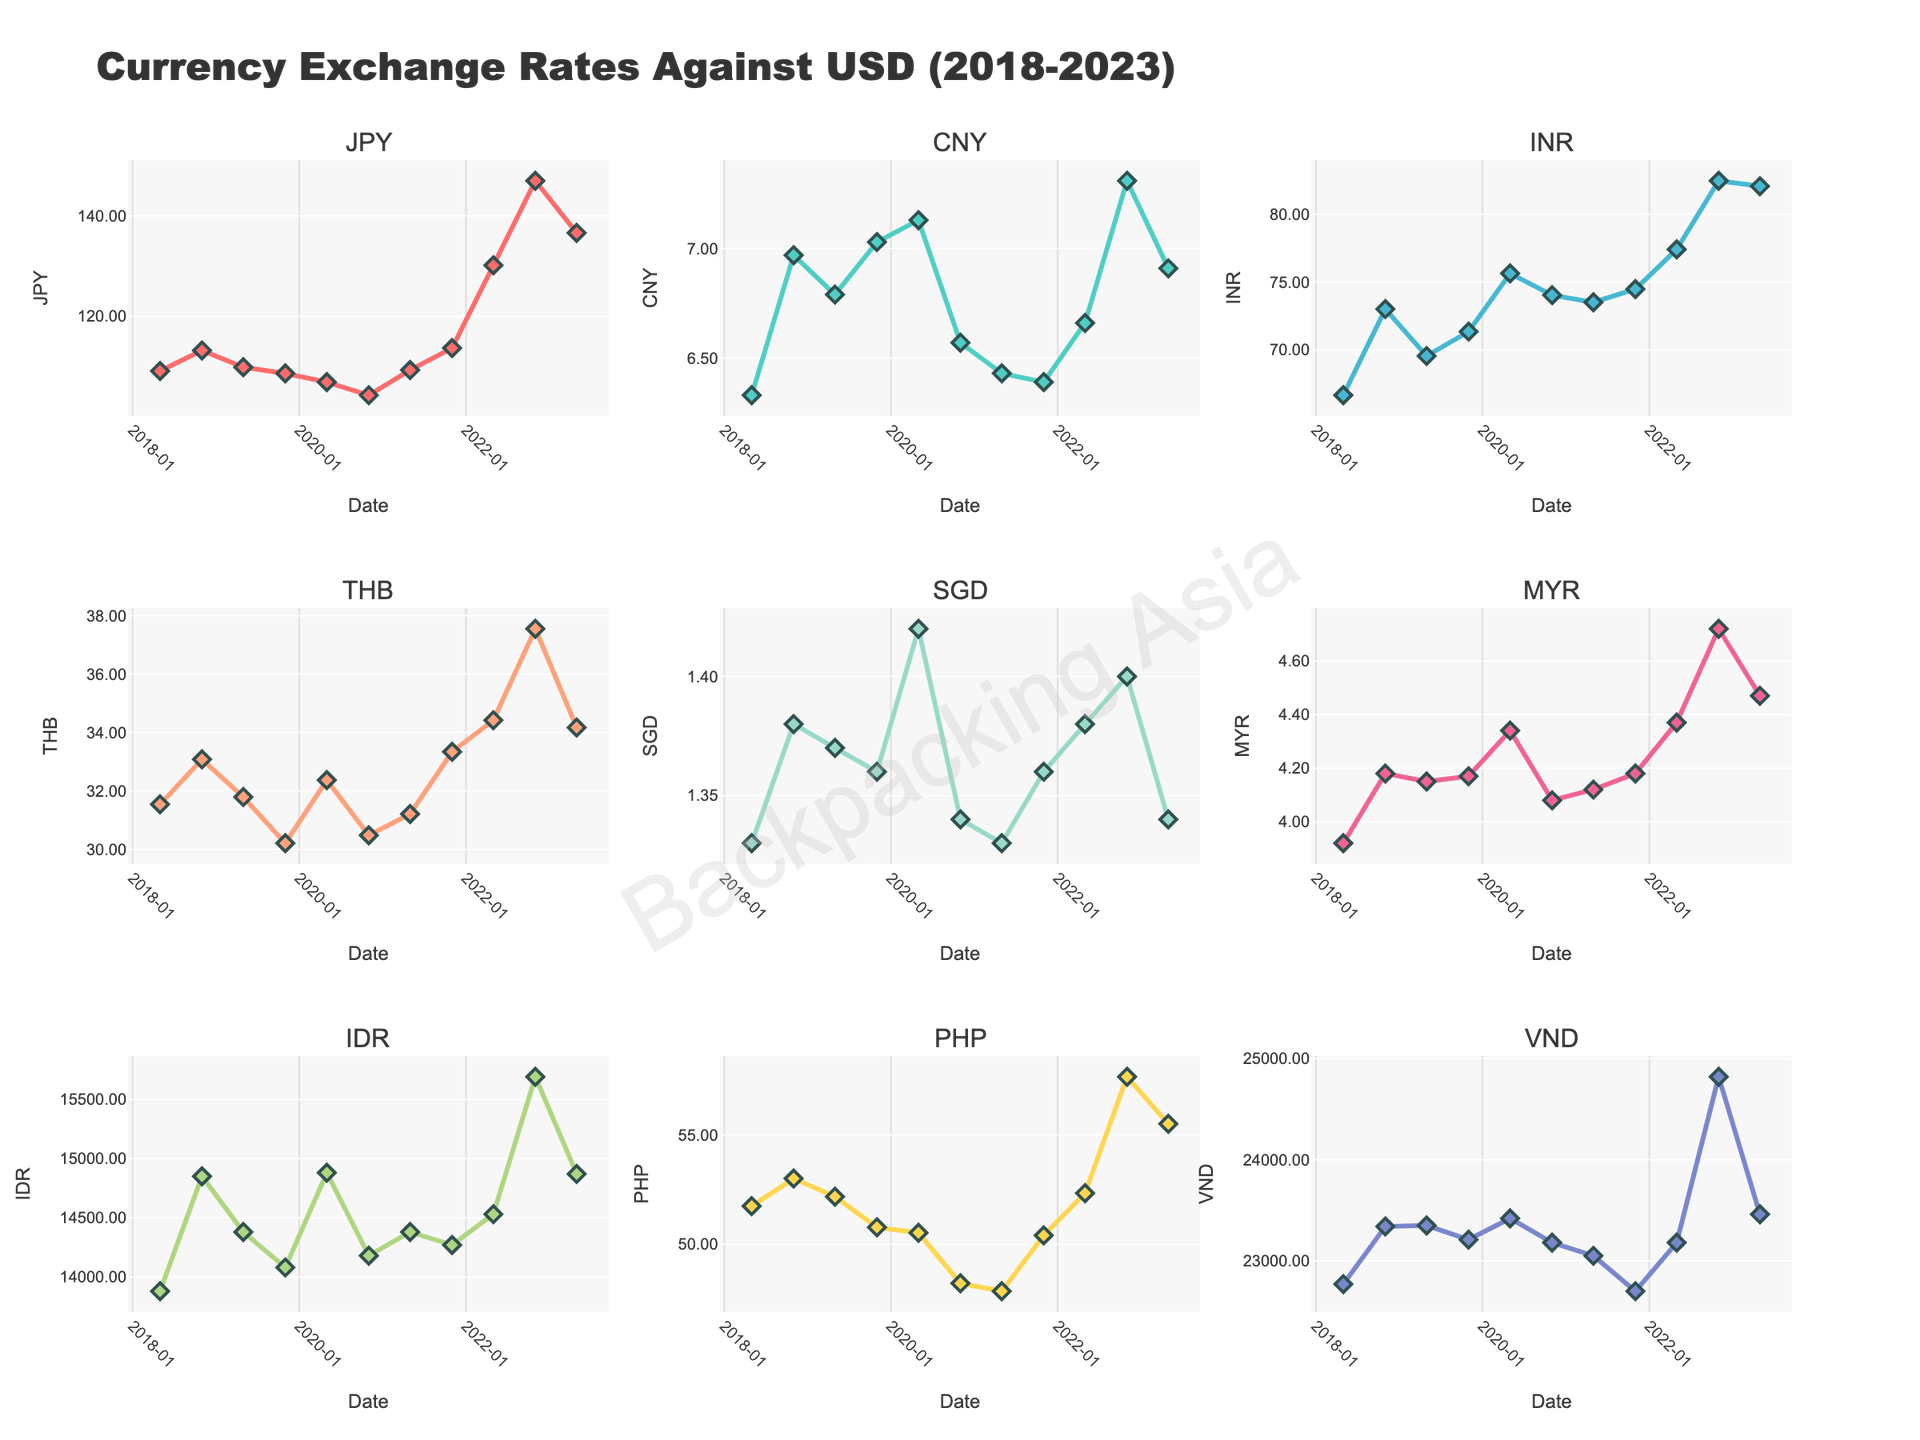Which currency has the overall highest exchange rate against USD in the last 5 years? Look at all the subplots to identify the currency with the highest peak value. The VND (Vietnamese Dong) consistently has the highest exchange rates with a peak around 25000 VND/USD.
Answer: VND Between May 2020 and November 2022, which currency appreciated the most against USD? Calculate the percentage change for each currency from May 2020 to November 2022 and identify the one with the largest increase. THB increased from 32.37 to 37.55, which is approximately 16%, representing the highest appreciation compared to other currencies in that period.
Answer: THB What is the overall trend for the JPY exchange rate over the past 5 years? Observe the JPY subplot for patterns. The JPY generally shows an appreciating trend against the USD, starting at around 109 JPY/USD in 2018 and peaking at around 147 JPY/USD in November 2022 before slightly decreasing.
Answer: Appreciating Which two currencies seem to have the most similar exchange rate trends over the last 5 years? Compare the shapes and patterns of the different subplots to find two currencies with similar direction and fluctuations. CNY and SGD show very similar trends, both maintaining relatively stable rates with slight fluctuations.
Answer: CNY and SGD During which period did the PHP experience the most significant decrease in its exchange rate against USD? Look at the PHP subplot and identify the sharpest downward slope. This occurs between May 2022 and November 2022, where the PHP/USD rate drops noticeably.
Answer: May 2022 to November 2022 What was the exchange rate of INR against USD in November 2020 compared to May 2023? Find the specific values for INR in November 2020 (74.04) and May 2023 (82.07) and compare them directly. The exchange rate increased from 74.04 INR/USD to 82.07 INR/USD.
Answer: 74.04 to 82.07 Which currency showed the least volatility in its exchange rate against USD over the past 5 years? Check the subplots and identify the currency with the smallest range or least fluctuation in its curve. The SGD shows the least volatility, maintaining an exchange rate around 1.33-1.42 SGD/USD.
Answer: SGD Which month and year did the IDR peak its highest exchange rate against USD within the given data? Locate the peak on the IDR subplot. The highest exchange rate of IDR is observed in November 2022.
Answer: November 2022 What is the visual difference between the exchange rate trends of MYR and THB from May 2021 to May 2022? Observe the trend lines in the MYR and THB subplots within the specified timeframe. MYR remains relatively stable around 4.12-4.37, while THB increases from around 31.21 to 34.42.
Answer: MYR stable, THB increasing 